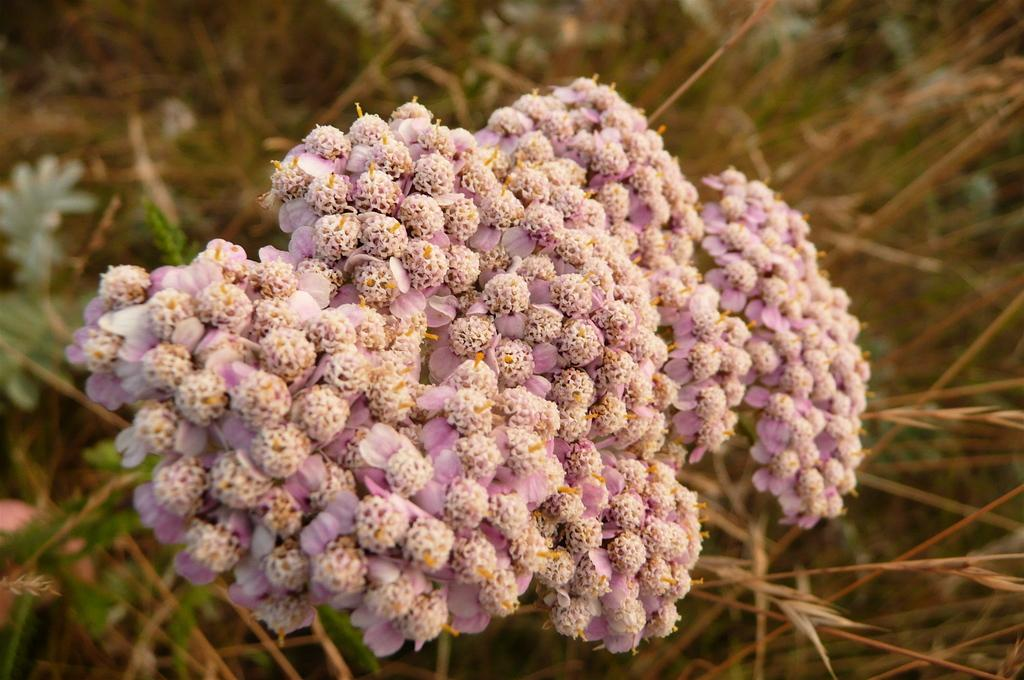What is the main subject of the image? There is a bunch of flowers in the image. How is the background of the image depicted? The background of the image has a blurred view. What other types of flora can be seen in the image? There are plants visible in the image. Are there any flowers other than the bunch in the image? Yes, there are flowers visible in the image. What type of letter is being written by the cook in the image? There is no cook or letter present in the image; it features a bunch of flowers and other flora. 